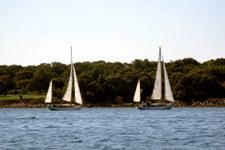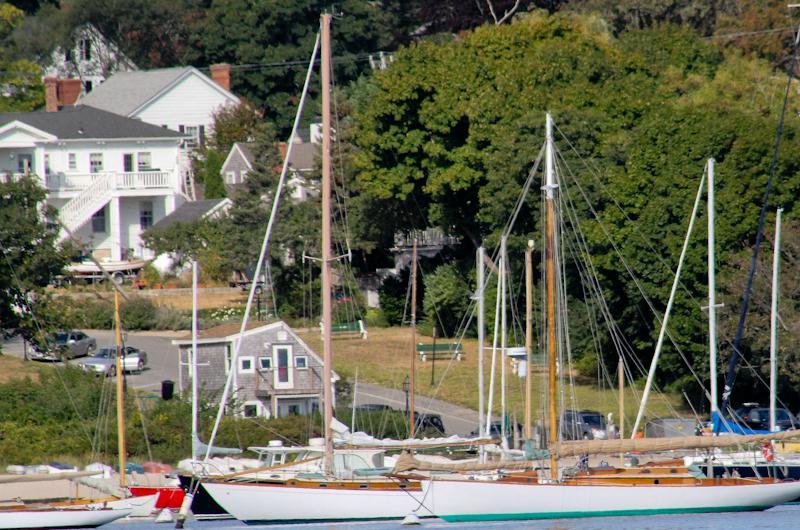The first image is the image on the left, the second image is the image on the right. Given the left and right images, does the statement "In the left image, there are two boats, regardless of buoyancy." hold true? Answer yes or no. Yes. The first image is the image on the left, the second image is the image on the right. Considering the images on both sides, is "There are multiple boats sailing in the left image." valid? Answer yes or no. Yes. 